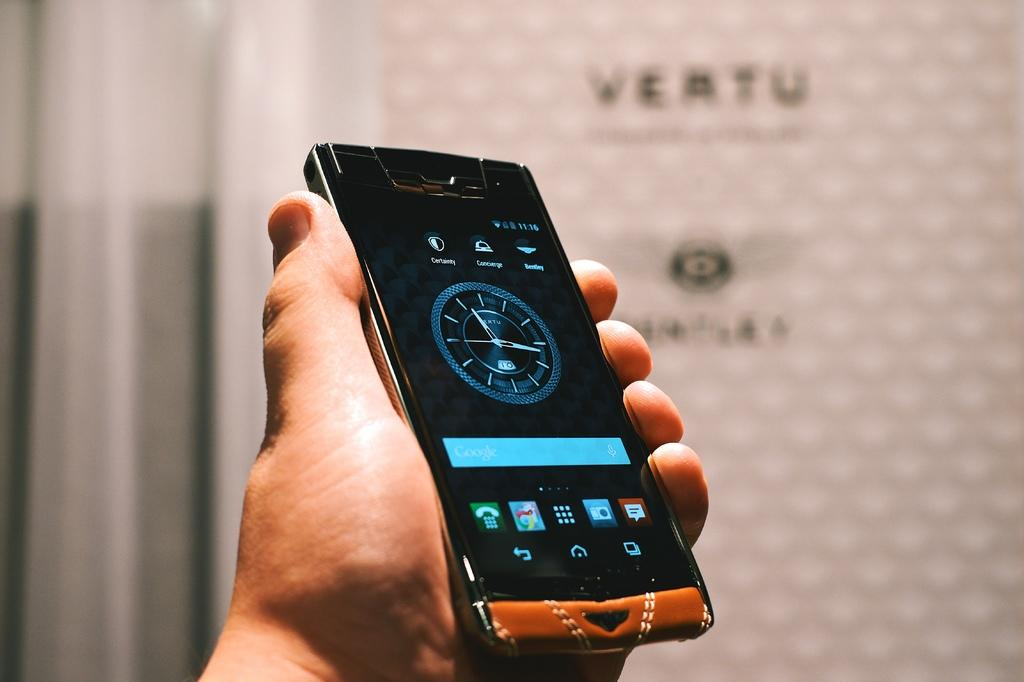<image>
Offer a succinct explanation of the picture presented. A person is holding a phone that has a clock on it and a Google search bar. 